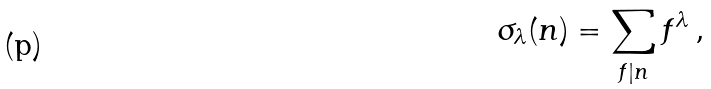Convert formula to latex. <formula><loc_0><loc_0><loc_500><loc_500>\sigma _ { \lambda } ( n ) = \sum _ { f | n } f ^ { \lambda } \, ,</formula> 